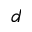Convert formula to latex. <formula><loc_0><loc_0><loc_500><loc_500>d</formula> 